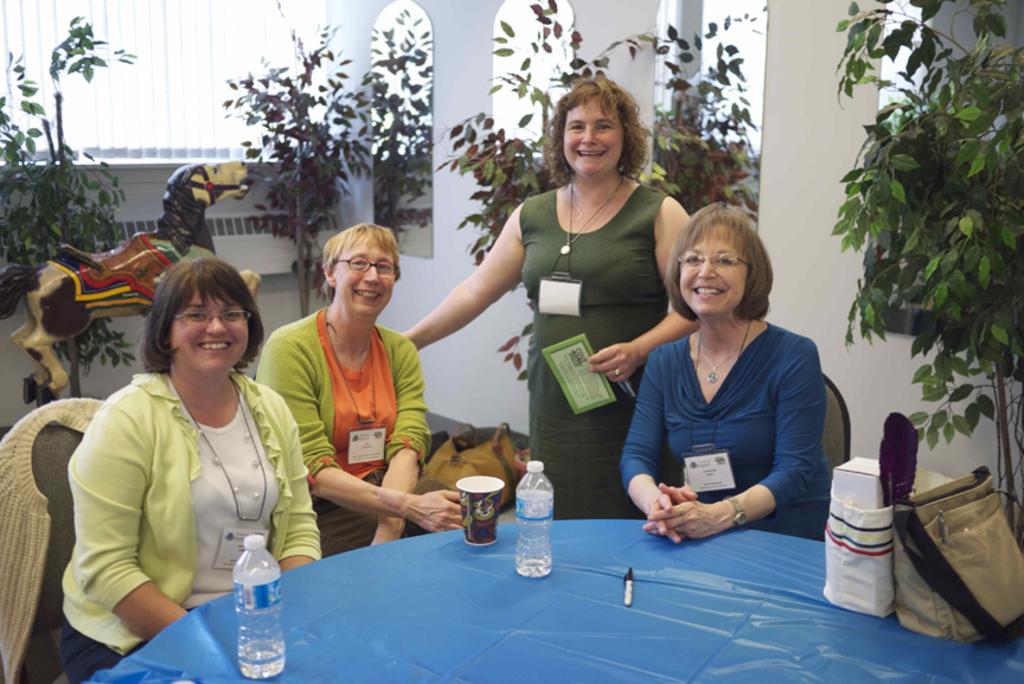Can you describe this image briefly? As we can see in the image there is a wall, plants, few people sitting on chairs and a table. On table there is a handbag, bottles and cup. 